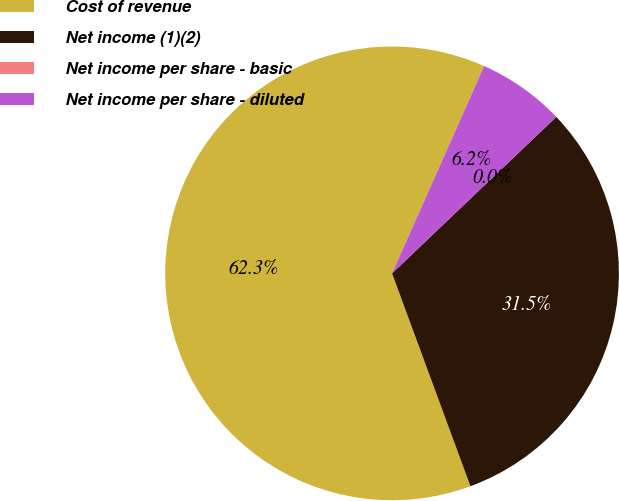<chart> <loc_0><loc_0><loc_500><loc_500><pie_chart><fcel>Cost of revenue<fcel>Net income (1)(2)<fcel>Net income per share - basic<fcel>Net income per share - diluted<nl><fcel>62.27%<fcel>31.5%<fcel>0.0%<fcel>6.23%<nl></chart> 